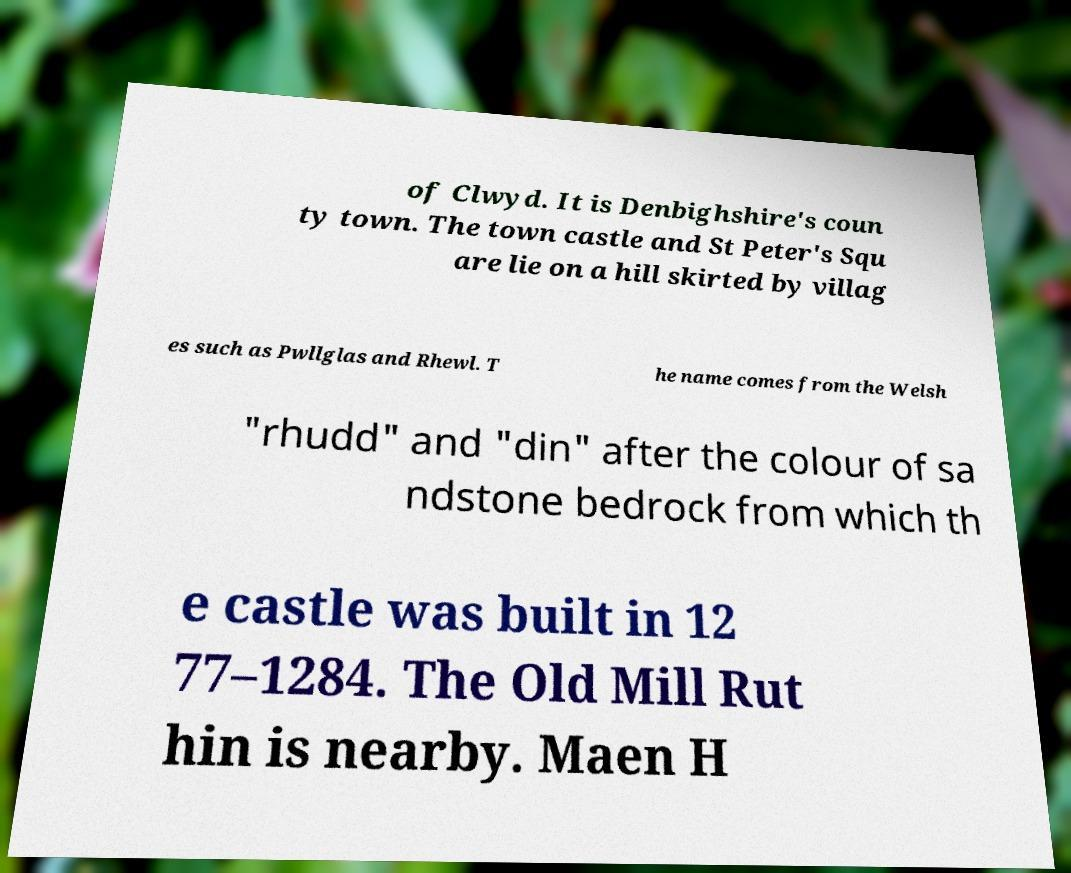What messages or text are displayed in this image? I need them in a readable, typed format. of Clwyd. It is Denbighshire's coun ty town. The town castle and St Peter's Squ are lie on a hill skirted by villag es such as Pwllglas and Rhewl. T he name comes from the Welsh "rhudd" and "din" after the colour of sa ndstone bedrock from which th e castle was built in 12 77–1284. The Old Mill Rut hin is nearby. Maen H 